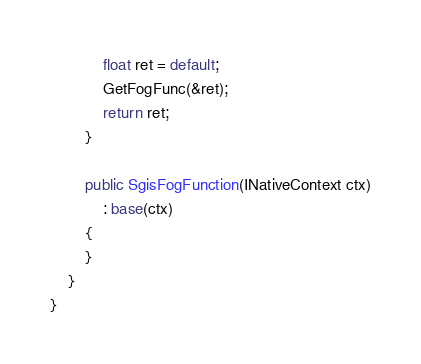Convert code to text. <code><loc_0><loc_0><loc_500><loc_500><_C#_>            float ret = default;
            GetFogFunc(&ret);
            return ret;
        }

        public SgisFogFunction(INativeContext ctx)
            : base(ctx)
        {
        }
    }
}

</code> 